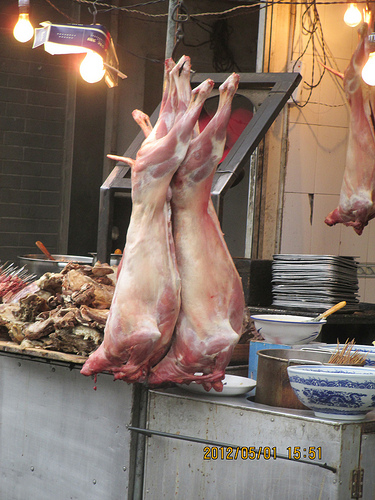<image>
Can you confirm if the animal carcass is to the left of the bowl? Yes. From this viewpoint, the animal carcass is positioned to the left side relative to the bowl. 